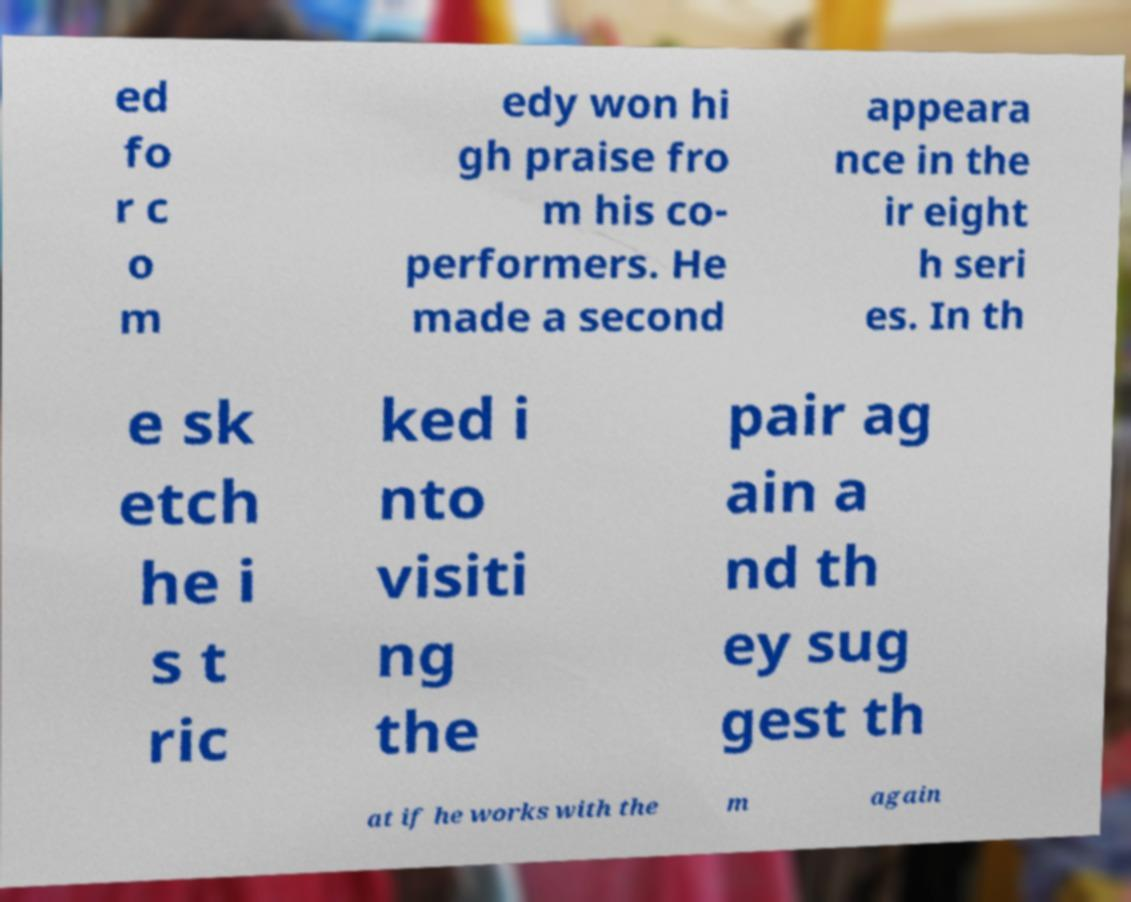There's text embedded in this image that I need extracted. Can you transcribe it verbatim? ed fo r c o m edy won hi gh praise fro m his co- performers. He made a second appeara nce in the ir eight h seri es. In th e sk etch he i s t ric ked i nto visiti ng the pair ag ain a nd th ey sug gest th at if he works with the m again 